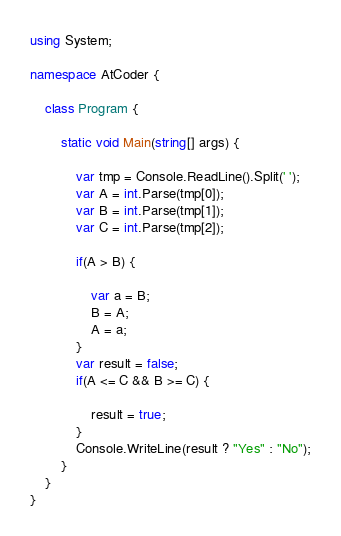<code> <loc_0><loc_0><loc_500><loc_500><_C#_>using System;

namespace AtCoder {

    class Program {

        static void Main(string[] args) {

            var tmp = Console.ReadLine().Split(' ');
            var A = int.Parse(tmp[0]);
            var B = int.Parse(tmp[1]);
            var C = int.Parse(tmp[2]);

            if(A > B) {

                var a = B;
                B = A;
                A = a;
            }
            var result = false;
            if(A <= C && B >= C) {

                result = true;
            }
            Console.WriteLine(result ? "Yes" : "No");
        }
    }
}
</code> 